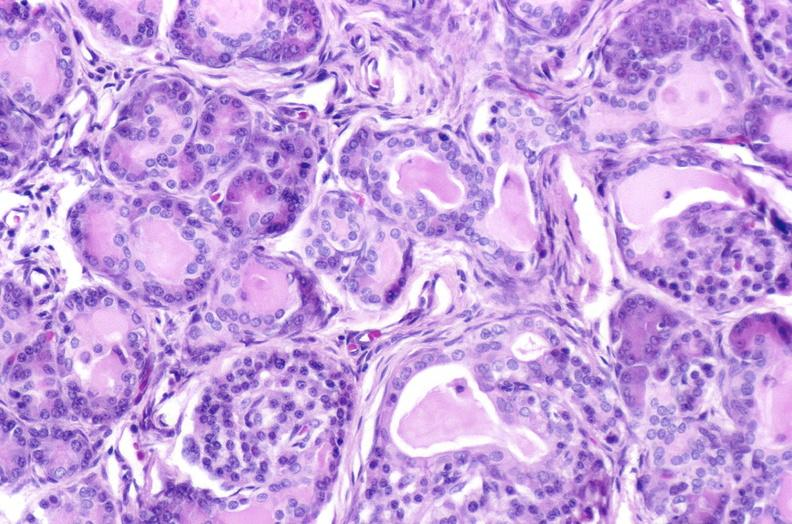where is this?
Answer the question using a single word or phrase. Pancreas 